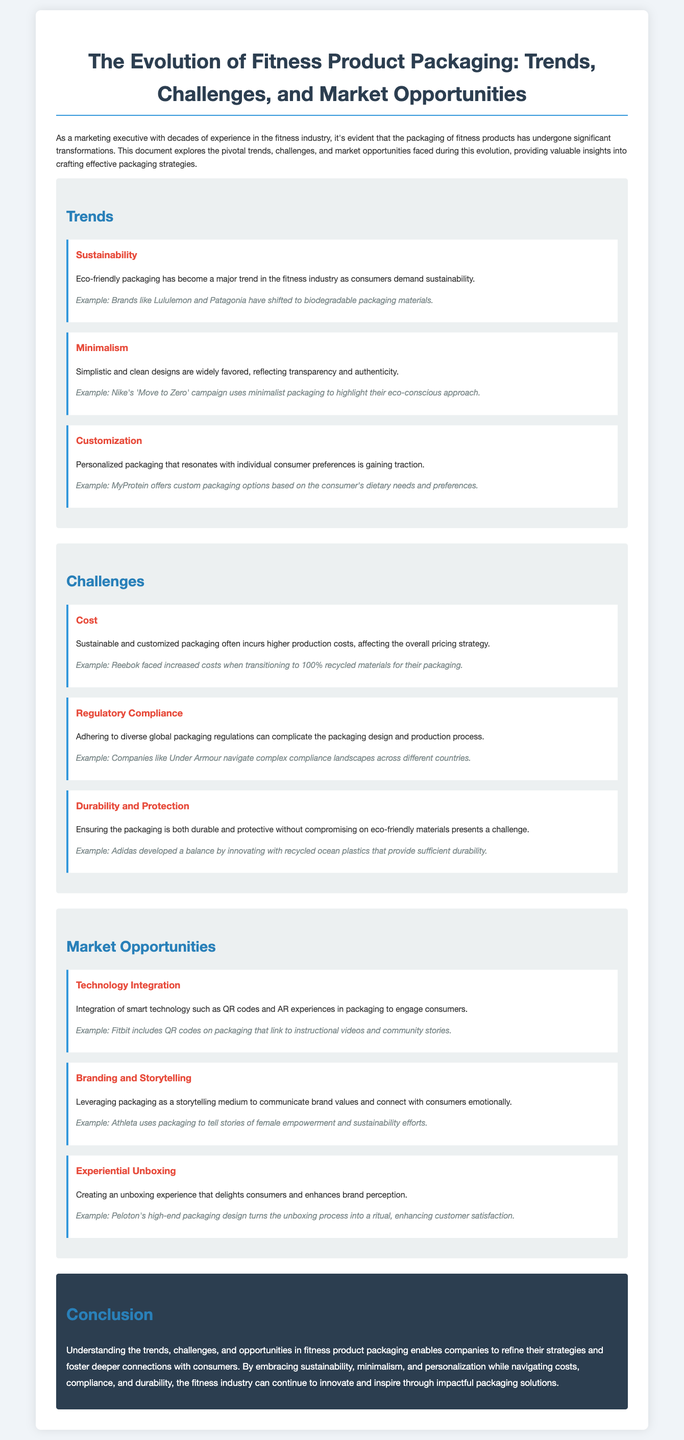What is a major trend in fitness product packaging? The document highlights sustainability as a major trend due to consumers’ demand for eco-friendly options.
Answer: Sustainability Which brand shifted to biodegradable packaging materials? Lululemon and Patagonia are mentioned as brands that have made this shift.
Answer: Lululemon and Patagonia What challenge involves higher production costs? The document indicates that the challenge of cost affects sustainable and customized packaging.
Answer: Cost Which company navigates complex compliance landscapes? Under Armour is specifically mentioned as a company facing regulatory compliance challenges.
Answer: Under Armour What does Adidas innovate with to ensure durability? Adidas innovates using recycled ocean plastics to maintain packaging durability.
Answer: Recycled ocean plastics What type of technology is integrated into fitness product packaging? The document discusses the integration of smart technology such as QR codes and AR experiences.
Answer: QR codes and AR experiences What storytelling medium does Athleta use? Athleta leverages packaging as a medium to communicate brand values and stories.
Answer: Packaging What is mentioned as a delightful consumer experience? The document refers to experiential unboxing as a way to enhance brand perception.
Answer: Experiential unboxing What should companies embrace according to the conclusion? Companies should embrace sustainability, minimalism, and personalization to innovate in packaging.
Answer: Sustainability, minimalism, and personalization 